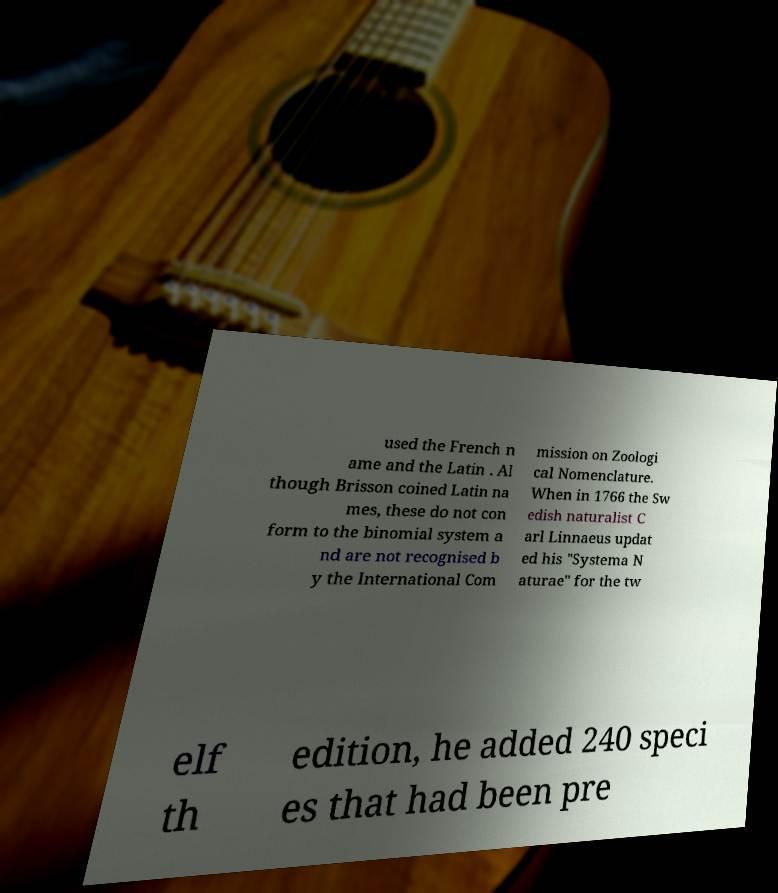There's text embedded in this image that I need extracted. Can you transcribe it verbatim? used the French n ame and the Latin . Al though Brisson coined Latin na mes, these do not con form to the binomial system a nd are not recognised b y the International Com mission on Zoologi cal Nomenclature. When in 1766 the Sw edish naturalist C arl Linnaeus updat ed his "Systema N aturae" for the tw elf th edition, he added 240 speci es that had been pre 